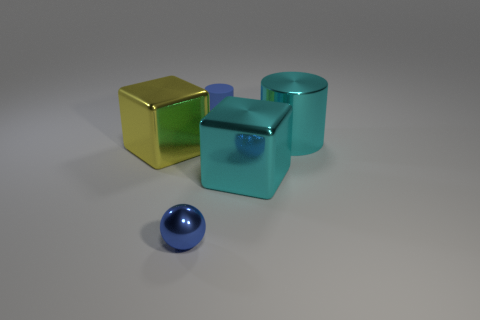Add 2 big metallic cubes. How many objects exist? 7 Subtract all balls. How many objects are left? 4 Add 2 large cyan metallic blocks. How many large cyan metallic blocks exist? 3 Subtract 0 red cubes. How many objects are left? 5 Subtract all large cyan metallic cubes. Subtract all large cyan cubes. How many objects are left? 3 Add 5 rubber objects. How many rubber objects are left? 6 